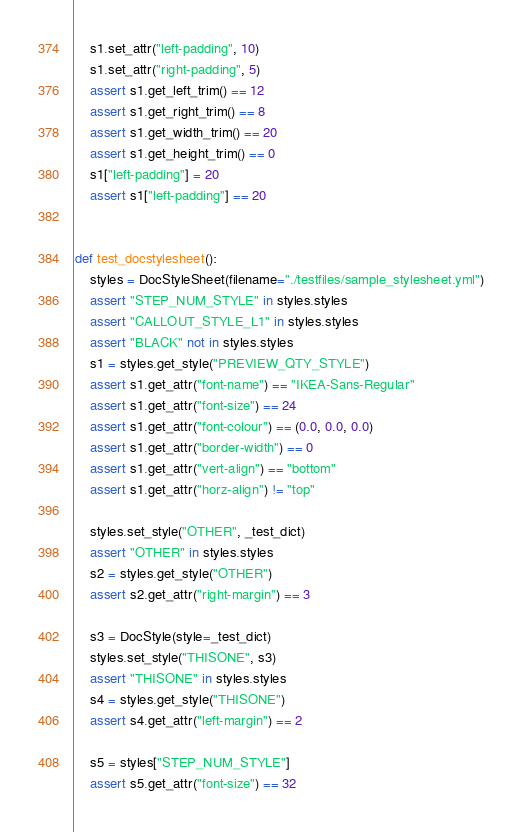Convert code to text. <code><loc_0><loc_0><loc_500><loc_500><_Python_>    s1.set_attr("left-padding", 10)
    s1.set_attr("right-padding", 5)
    assert s1.get_left_trim() == 12
    assert s1.get_right_trim() == 8
    assert s1.get_width_trim() == 20
    assert s1.get_height_trim() == 0
    s1["left-padding"] = 20
    assert s1["left-padding"] == 20


def test_docstylesheet():
    styles = DocStyleSheet(filename="./testfiles/sample_stylesheet.yml")
    assert "STEP_NUM_STYLE" in styles.styles
    assert "CALLOUT_STYLE_L1" in styles.styles
    assert "BLACK" not in styles.styles
    s1 = styles.get_style("PREVIEW_QTY_STYLE")
    assert s1.get_attr("font-name") == "IKEA-Sans-Regular"
    assert s1.get_attr("font-size") == 24
    assert s1.get_attr("font-colour") == (0.0, 0.0, 0.0)
    assert s1.get_attr("border-width") == 0
    assert s1.get_attr("vert-align") == "bottom"
    assert s1.get_attr("horz-align") != "top"

    styles.set_style("OTHER", _test_dict)
    assert "OTHER" in styles.styles
    s2 = styles.get_style("OTHER")
    assert s2.get_attr("right-margin") == 3

    s3 = DocStyle(style=_test_dict)
    styles.set_style("THISONE", s3)
    assert "THISONE" in styles.styles
    s4 = styles.get_style("THISONE")
    assert s4.get_attr("left-margin") == 2

    s5 = styles["STEP_NUM_STYLE"]
    assert s5.get_attr("font-size") == 32
</code> 